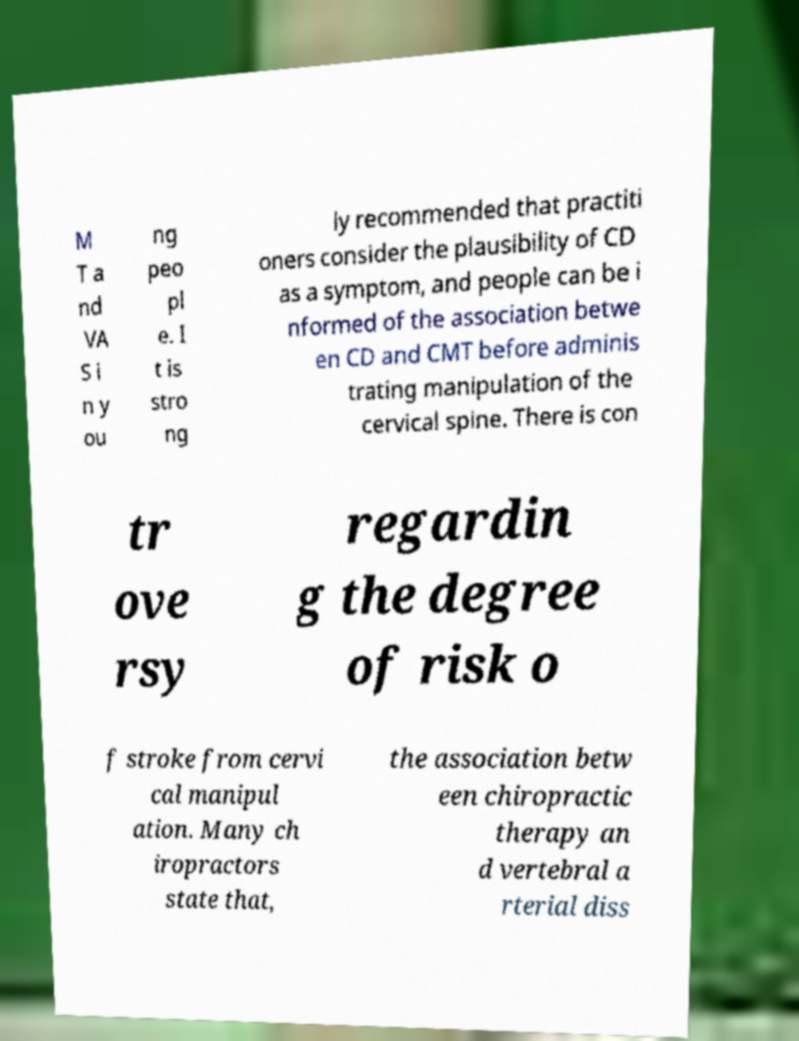I need the written content from this picture converted into text. Can you do that? M T a nd VA S i n y ou ng peo pl e. I t is stro ng ly recommended that practiti oners consider the plausibility of CD as a symptom, and people can be i nformed of the association betwe en CD and CMT before adminis trating manipulation of the cervical spine. There is con tr ove rsy regardin g the degree of risk o f stroke from cervi cal manipul ation. Many ch iropractors state that, the association betw een chiropractic therapy an d vertebral a rterial diss 